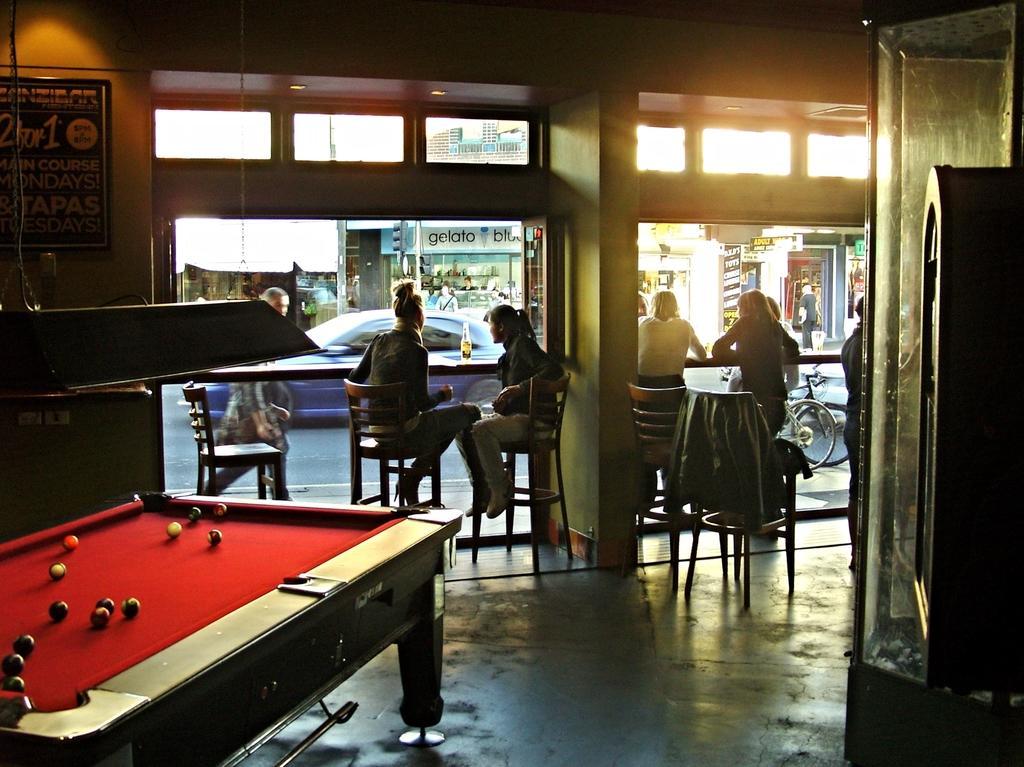Describe this image in one or two sentences. There are two women sitting on the chairs and there are three,four women sitting beside them. It looks like an restaurant. And there is a man walking outside the restaurant,And I can see a blue colored car going on the road. And there is a glass Bottle,It looks like a beer bottle placed on the top of the table. And I can see a bicycles parked outside the restaurant. And there is a photo frame which was hanged to the wall. And I can see a snooker table with a balls placed on it. I can see shops outside the restaurant,and here a old man/woman is standing on the road. And I can see a chair and some kind of jerkin is placed on the chair. 